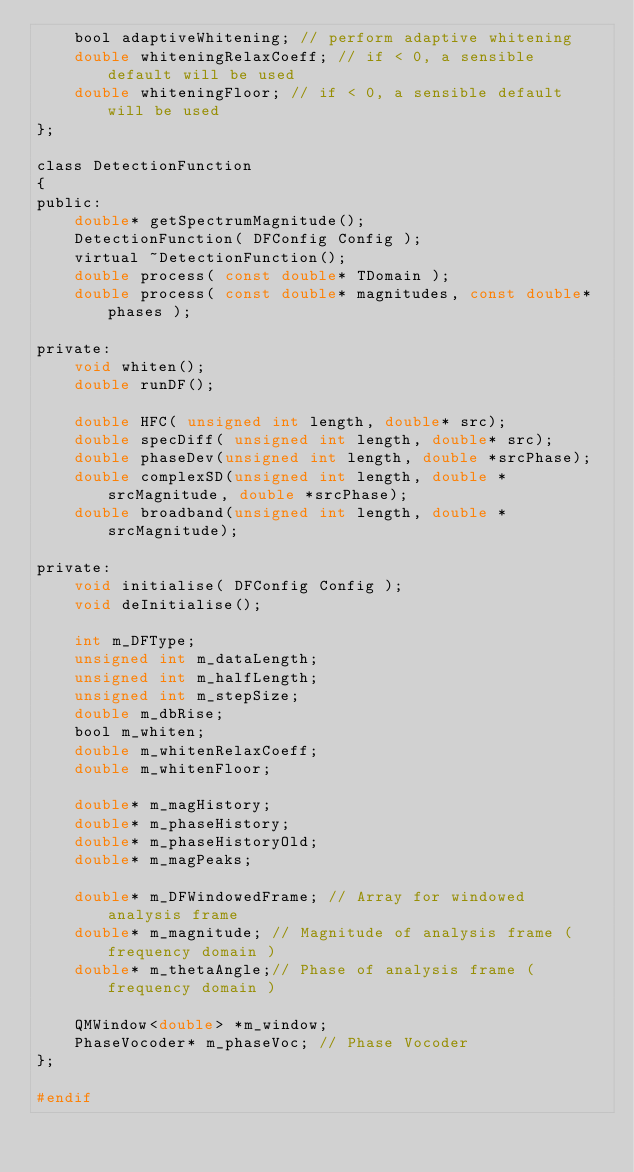Convert code to text. <code><loc_0><loc_0><loc_500><loc_500><_C_>    bool adaptiveWhitening; // perform adaptive whitening
    double whiteningRelaxCoeff; // if < 0, a sensible default will be used
    double whiteningFloor; // if < 0, a sensible default will be used
};

class DetectionFunction  
{
public:
    double* getSpectrumMagnitude();
    DetectionFunction( DFConfig Config );
    virtual ~DetectionFunction();
    double process( const double* TDomain );
    double process( const double* magnitudes, const double* phases );

private:
    void whiten();
    double runDF();

    double HFC( unsigned int length, double* src);
    double specDiff( unsigned int length, double* src);
    double phaseDev(unsigned int length, double *srcPhase);
    double complexSD(unsigned int length, double *srcMagnitude, double *srcPhase);
    double broadband(unsigned int length, double *srcMagnitude);
	
private:
    void initialise( DFConfig Config );
    void deInitialise();

    int m_DFType;
    unsigned int m_dataLength;
    unsigned int m_halfLength;
    unsigned int m_stepSize;
    double m_dbRise;
    bool m_whiten;
    double m_whitenRelaxCoeff;
    double m_whitenFloor;

    double* m_magHistory;
    double* m_phaseHistory;
    double* m_phaseHistoryOld;
    double* m_magPeaks;

    double* m_DFWindowedFrame; // Array for windowed analysis frame
    double* m_magnitude; // Magnitude of analysis frame ( frequency domain )
    double* m_thetaAngle;// Phase of analysis frame ( frequency domain )

    QMWindow<double> *m_window;
    PhaseVocoder* m_phaseVoc;	// Phase Vocoder
};

#endif 
</code> 